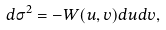<formula> <loc_0><loc_0><loc_500><loc_500>d \sigma ^ { 2 } = - W ( u , v ) d u d v ,</formula> 